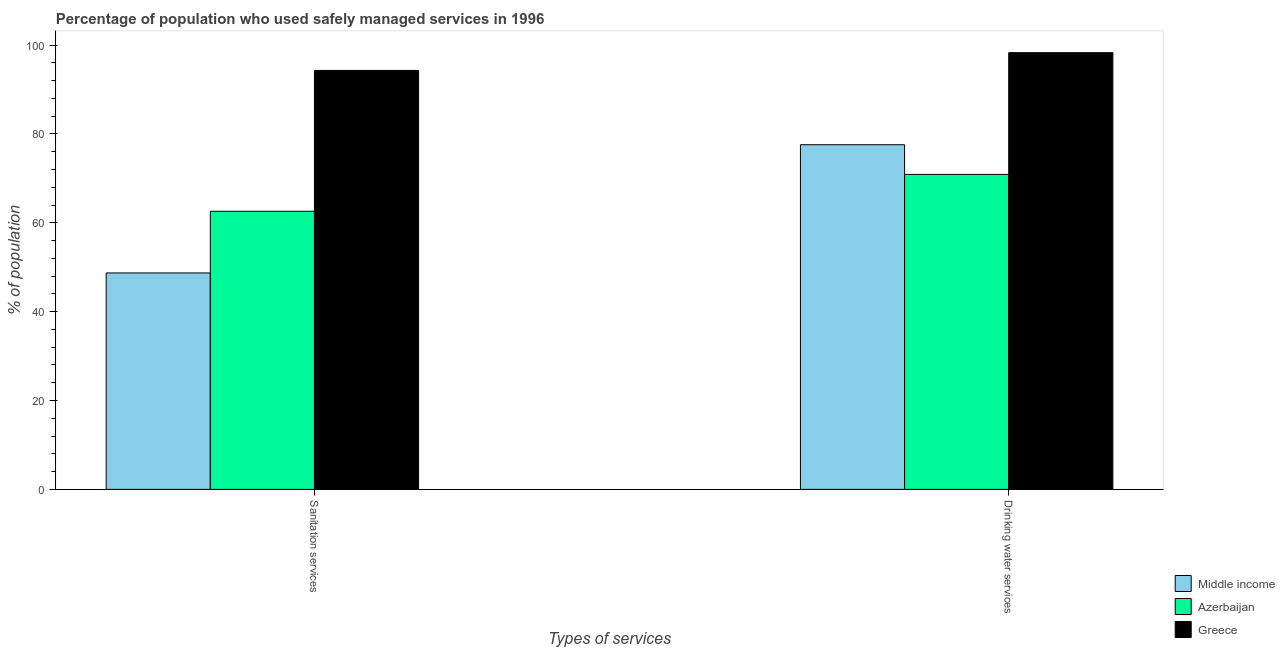How many different coloured bars are there?
Your answer should be compact. 3. Are the number of bars per tick equal to the number of legend labels?
Ensure brevity in your answer.  Yes. How many bars are there on the 2nd tick from the left?
Keep it short and to the point. 3. What is the label of the 1st group of bars from the left?
Give a very brief answer. Sanitation services. What is the percentage of population who used drinking water services in Middle income?
Offer a very short reply. 77.58. Across all countries, what is the maximum percentage of population who used drinking water services?
Give a very brief answer. 98.3. Across all countries, what is the minimum percentage of population who used sanitation services?
Offer a very short reply. 48.72. In which country was the percentage of population who used drinking water services maximum?
Your answer should be compact. Greece. What is the total percentage of population who used sanitation services in the graph?
Your answer should be very brief. 205.62. What is the difference between the percentage of population who used drinking water services in Azerbaijan and that in Greece?
Your answer should be very brief. -27.4. What is the difference between the percentage of population who used drinking water services in Greece and the percentage of population who used sanitation services in Middle income?
Your answer should be very brief. 49.58. What is the average percentage of population who used drinking water services per country?
Keep it short and to the point. 82.26. What is the difference between the percentage of population who used sanitation services and percentage of population who used drinking water services in Greece?
Give a very brief answer. -4. What is the ratio of the percentage of population who used sanitation services in Middle income to that in Greece?
Your response must be concise. 0.52. Is the percentage of population who used drinking water services in Greece less than that in Middle income?
Offer a very short reply. No. What does the 2nd bar from the left in Sanitation services represents?
Offer a very short reply. Azerbaijan. How many bars are there?
Keep it short and to the point. 6. How many countries are there in the graph?
Ensure brevity in your answer.  3. What is the difference between two consecutive major ticks on the Y-axis?
Ensure brevity in your answer.  20. Are the values on the major ticks of Y-axis written in scientific E-notation?
Your answer should be very brief. No. Does the graph contain grids?
Your answer should be very brief. No. Where does the legend appear in the graph?
Your answer should be compact. Bottom right. How many legend labels are there?
Ensure brevity in your answer.  3. How are the legend labels stacked?
Keep it short and to the point. Vertical. What is the title of the graph?
Ensure brevity in your answer.  Percentage of population who used safely managed services in 1996. What is the label or title of the X-axis?
Give a very brief answer. Types of services. What is the label or title of the Y-axis?
Provide a short and direct response. % of population. What is the % of population in Middle income in Sanitation services?
Offer a very short reply. 48.72. What is the % of population of Azerbaijan in Sanitation services?
Offer a terse response. 62.6. What is the % of population of Greece in Sanitation services?
Offer a very short reply. 94.3. What is the % of population of Middle income in Drinking water services?
Ensure brevity in your answer.  77.58. What is the % of population of Azerbaijan in Drinking water services?
Offer a very short reply. 70.9. What is the % of population of Greece in Drinking water services?
Give a very brief answer. 98.3. Across all Types of services, what is the maximum % of population in Middle income?
Offer a very short reply. 77.58. Across all Types of services, what is the maximum % of population of Azerbaijan?
Ensure brevity in your answer.  70.9. Across all Types of services, what is the maximum % of population in Greece?
Your answer should be very brief. 98.3. Across all Types of services, what is the minimum % of population in Middle income?
Your answer should be compact. 48.72. Across all Types of services, what is the minimum % of population in Azerbaijan?
Provide a short and direct response. 62.6. Across all Types of services, what is the minimum % of population of Greece?
Your response must be concise. 94.3. What is the total % of population in Middle income in the graph?
Your response must be concise. 126.3. What is the total % of population of Azerbaijan in the graph?
Your response must be concise. 133.5. What is the total % of population in Greece in the graph?
Offer a very short reply. 192.6. What is the difference between the % of population of Middle income in Sanitation services and that in Drinking water services?
Your answer should be very brief. -28.86. What is the difference between the % of population in Greece in Sanitation services and that in Drinking water services?
Your answer should be compact. -4. What is the difference between the % of population of Middle income in Sanitation services and the % of population of Azerbaijan in Drinking water services?
Provide a short and direct response. -22.18. What is the difference between the % of population of Middle income in Sanitation services and the % of population of Greece in Drinking water services?
Provide a short and direct response. -49.58. What is the difference between the % of population in Azerbaijan in Sanitation services and the % of population in Greece in Drinking water services?
Your answer should be compact. -35.7. What is the average % of population of Middle income per Types of services?
Provide a short and direct response. 63.15. What is the average % of population of Azerbaijan per Types of services?
Give a very brief answer. 66.75. What is the average % of population in Greece per Types of services?
Provide a succinct answer. 96.3. What is the difference between the % of population in Middle income and % of population in Azerbaijan in Sanitation services?
Your response must be concise. -13.88. What is the difference between the % of population in Middle income and % of population in Greece in Sanitation services?
Your answer should be very brief. -45.58. What is the difference between the % of population of Azerbaijan and % of population of Greece in Sanitation services?
Your answer should be compact. -31.7. What is the difference between the % of population in Middle income and % of population in Azerbaijan in Drinking water services?
Offer a terse response. 6.68. What is the difference between the % of population in Middle income and % of population in Greece in Drinking water services?
Ensure brevity in your answer.  -20.72. What is the difference between the % of population in Azerbaijan and % of population in Greece in Drinking water services?
Provide a short and direct response. -27.4. What is the ratio of the % of population in Middle income in Sanitation services to that in Drinking water services?
Your response must be concise. 0.63. What is the ratio of the % of population in Azerbaijan in Sanitation services to that in Drinking water services?
Your response must be concise. 0.88. What is the ratio of the % of population of Greece in Sanitation services to that in Drinking water services?
Keep it short and to the point. 0.96. What is the difference between the highest and the second highest % of population in Middle income?
Provide a succinct answer. 28.86. What is the difference between the highest and the second highest % of population of Greece?
Provide a short and direct response. 4. What is the difference between the highest and the lowest % of population in Middle income?
Give a very brief answer. 28.86. What is the difference between the highest and the lowest % of population in Azerbaijan?
Provide a succinct answer. 8.3. 